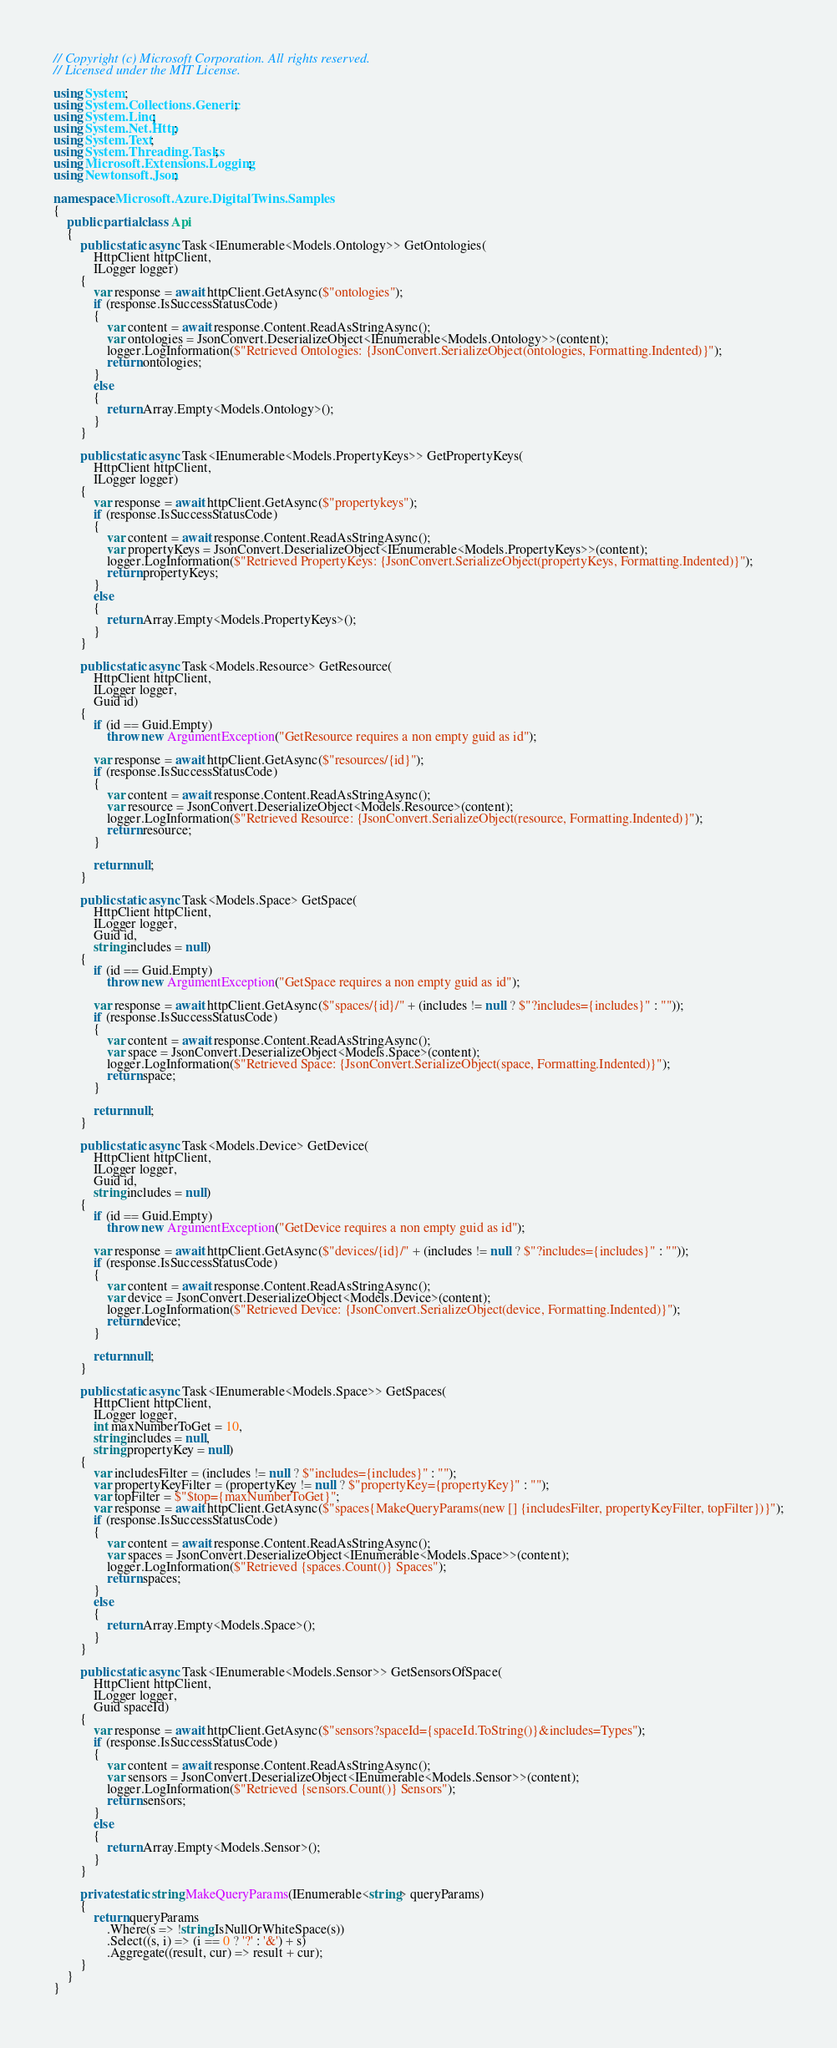<code> <loc_0><loc_0><loc_500><loc_500><_C#_>// Copyright (c) Microsoft Corporation. All rights reserved.
// Licensed under the MIT License.

using System;
using System.Collections.Generic;
using System.Linq;
using System.Net.Http;
using System.Text;
using System.Threading.Tasks;
using Microsoft.Extensions.Logging;
using Newtonsoft.Json;

namespace Microsoft.Azure.DigitalTwins.Samples
{
    public partial class Api
    {
        public static async Task<IEnumerable<Models.Ontology>> GetOntologies(
            HttpClient httpClient,
            ILogger logger)
        {
            var response = await httpClient.GetAsync($"ontologies");
            if (response.IsSuccessStatusCode)
            {
                var content = await response.Content.ReadAsStringAsync();
                var ontologies = JsonConvert.DeserializeObject<IEnumerable<Models.Ontology>>(content);
                logger.LogInformation($"Retrieved Ontologies: {JsonConvert.SerializeObject(ontologies, Formatting.Indented)}");
                return ontologies;
            }
            else
            {
                return Array.Empty<Models.Ontology>();
            }
        }

        public static async Task<IEnumerable<Models.PropertyKeys>> GetPropertyKeys(
            HttpClient httpClient,
            ILogger logger)
        {
            var response = await httpClient.GetAsync($"propertykeys");
            if (response.IsSuccessStatusCode)
            {
                var content = await response.Content.ReadAsStringAsync();
                var propertyKeys = JsonConvert.DeserializeObject<IEnumerable<Models.PropertyKeys>>(content);
                logger.LogInformation($"Retrieved PropertyKeys: {JsonConvert.SerializeObject(propertyKeys, Formatting.Indented)}");
                return propertyKeys;
            }
            else
            {
                return Array.Empty<Models.PropertyKeys>();
            }
        }

        public static async Task<Models.Resource> GetResource(
            HttpClient httpClient,
            ILogger logger,
            Guid id)
        {
            if (id == Guid.Empty)
                throw new ArgumentException("GetResource requires a non empty guid as id");

            var response = await httpClient.GetAsync($"resources/{id}");
            if (response.IsSuccessStatusCode)
            {
                var content = await response.Content.ReadAsStringAsync();
                var resource = JsonConvert.DeserializeObject<Models.Resource>(content);
                logger.LogInformation($"Retrieved Resource: {JsonConvert.SerializeObject(resource, Formatting.Indented)}");
                return resource;
            }

            return null;
        }

        public static async Task<Models.Space> GetSpace(
            HttpClient httpClient,
            ILogger logger,
            Guid id,
            string includes = null)
        {
            if (id == Guid.Empty)
                throw new ArgumentException("GetSpace requires a non empty guid as id");

            var response = await httpClient.GetAsync($"spaces/{id}/" + (includes != null ? $"?includes={includes}" : ""));
            if (response.IsSuccessStatusCode)
            {
                var content = await response.Content.ReadAsStringAsync();
                var space = JsonConvert.DeserializeObject<Models.Space>(content);
                logger.LogInformation($"Retrieved Space: {JsonConvert.SerializeObject(space, Formatting.Indented)}");
                return space;
            }

            return null;
        }

        public static async Task<Models.Device> GetDevice(
            HttpClient httpClient,
            ILogger logger,
            Guid id,
            string includes = null)
        {
            if (id == Guid.Empty)
                throw new ArgumentException("GetDevice requires a non empty guid as id");

            var response = await httpClient.GetAsync($"devices/{id}/" + (includes != null ? $"?includes={includes}" : ""));
            if (response.IsSuccessStatusCode)
            {
                var content = await response.Content.ReadAsStringAsync();
                var device = JsonConvert.DeserializeObject<Models.Device>(content);
                logger.LogInformation($"Retrieved Device: {JsonConvert.SerializeObject(device, Formatting.Indented)}");
                return device;
            }

            return null;
        }

        public static async Task<IEnumerable<Models.Space>> GetSpaces(
            HttpClient httpClient,
            ILogger logger,
            int maxNumberToGet = 10,
            string includes = null,
            string propertyKey = null)
        {
            var includesFilter = (includes != null ? $"includes={includes}" : "");
            var propertyKeyFilter = (propertyKey != null ? $"propertyKey={propertyKey}" : "");
            var topFilter = $"$top={maxNumberToGet}";
            var response = await httpClient.GetAsync($"spaces{MakeQueryParams(new [] {includesFilter, propertyKeyFilter, topFilter})}");
            if (response.IsSuccessStatusCode)
            {
                var content = await response.Content.ReadAsStringAsync();
                var spaces = JsonConvert.DeserializeObject<IEnumerable<Models.Space>>(content);
                logger.LogInformation($"Retrieved {spaces.Count()} Spaces");
                return spaces;
            }
            else
            {
                return Array.Empty<Models.Space>();
            }
        }

        public static async Task<IEnumerable<Models.Sensor>> GetSensorsOfSpace(
            HttpClient httpClient,
            ILogger logger,
            Guid spaceId)
        {
            var response = await httpClient.GetAsync($"sensors?spaceId={spaceId.ToString()}&includes=Types");
            if (response.IsSuccessStatusCode)
            {
                var content = await response.Content.ReadAsStringAsync();
                var sensors = JsonConvert.DeserializeObject<IEnumerable<Models.Sensor>>(content);
                logger.LogInformation($"Retrieved {sensors.Count()} Sensors");
                return sensors;
            }
            else
            {
                return Array.Empty<Models.Sensor>();
            }
        }

        private static string MakeQueryParams(IEnumerable<string> queryParams)
        {
            return queryParams
                .Where(s => !string.IsNullOrWhiteSpace(s))
                .Select((s, i) => (i == 0 ? '?' : '&') + s)
                .Aggregate((result, cur) => result + cur);
        }
    }
}</code> 